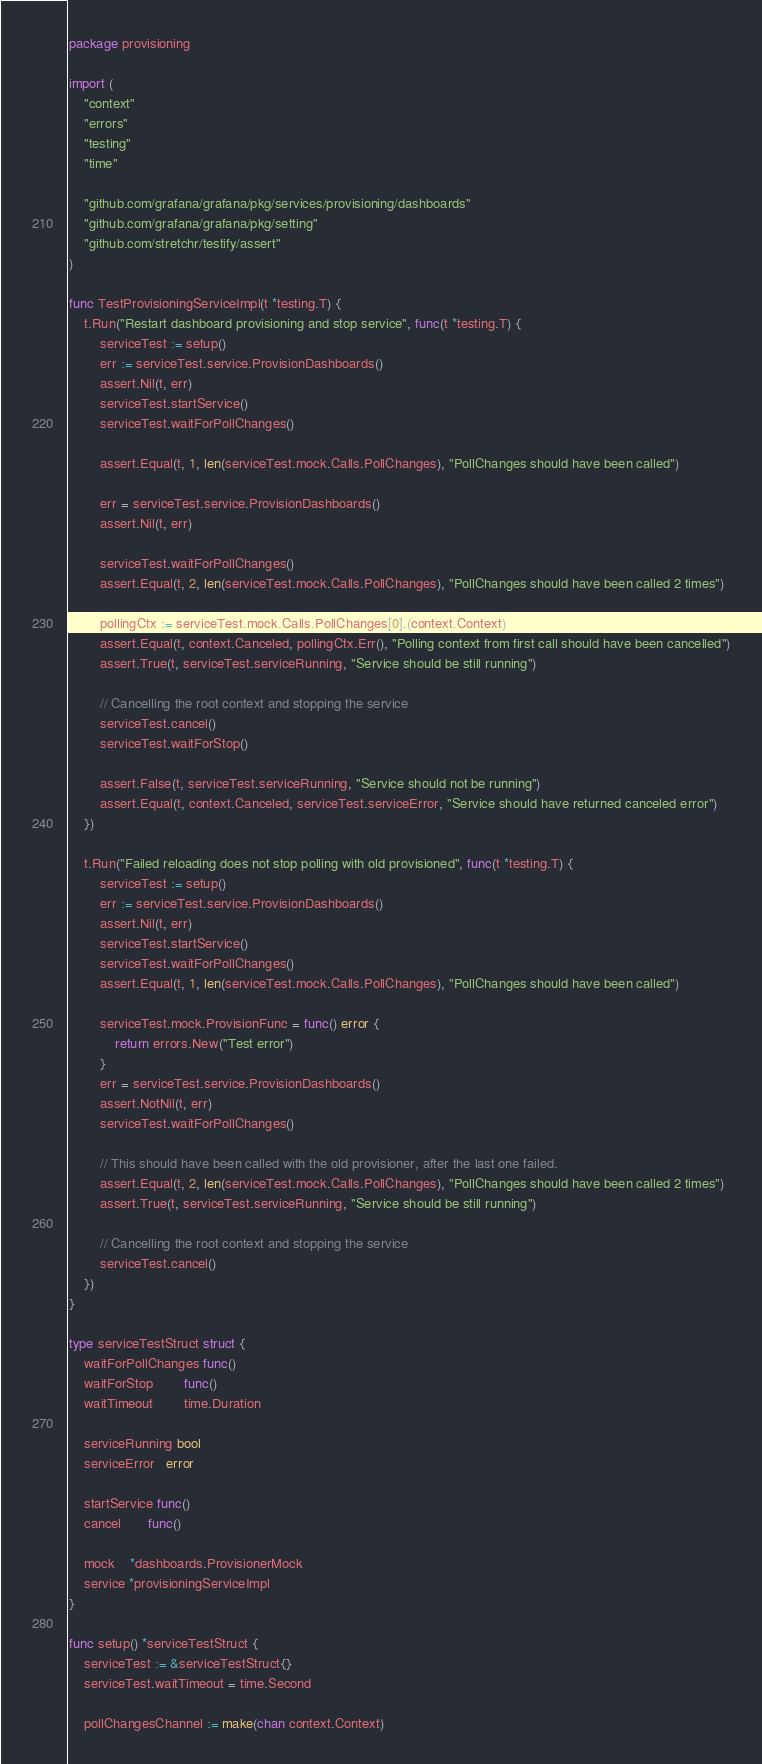Convert code to text. <code><loc_0><loc_0><loc_500><loc_500><_Go_>package provisioning

import (
	"context"
	"errors"
	"testing"
	"time"

	"github.com/grafana/grafana/pkg/services/provisioning/dashboards"
	"github.com/grafana/grafana/pkg/setting"
	"github.com/stretchr/testify/assert"
)

func TestProvisioningServiceImpl(t *testing.T) {
	t.Run("Restart dashboard provisioning and stop service", func(t *testing.T) {
		serviceTest := setup()
		err := serviceTest.service.ProvisionDashboards()
		assert.Nil(t, err)
		serviceTest.startService()
		serviceTest.waitForPollChanges()

		assert.Equal(t, 1, len(serviceTest.mock.Calls.PollChanges), "PollChanges should have been called")

		err = serviceTest.service.ProvisionDashboards()
		assert.Nil(t, err)

		serviceTest.waitForPollChanges()
		assert.Equal(t, 2, len(serviceTest.mock.Calls.PollChanges), "PollChanges should have been called 2 times")

		pollingCtx := serviceTest.mock.Calls.PollChanges[0].(context.Context)
		assert.Equal(t, context.Canceled, pollingCtx.Err(), "Polling context from first call should have been cancelled")
		assert.True(t, serviceTest.serviceRunning, "Service should be still running")

		// Cancelling the root context and stopping the service
		serviceTest.cancel()
		serviceTest.waitForStop()

		assert.False(t, serviceTest.serviceRunning, "Service should not be running")
		assert.Equal(t, context.Canceled, serviceTest.serviceError, "Service should have returned canceled error")
	})

	t.Run("Failed reloading does not stop polling with old provisioned", func(t *testing.T) {
		serviceTest := setup()
		err := serviceTest.service.ProvisionDashboards()
		assert.Nil(t, err)
		serviceTest.startService()
		serviceTest.waitForPollChanges()
		assert.Equal(t, 1, len(serviceTest.mock.Calls.PollChanges), "PollChanges should have been called")

		serviceTest.mock.ProvisionFunc = func() error {
			return errors.New("Test error")
		}
		err = serviceTest.service.ProvisionDashboards()
		assert.NotNil(t, err)
		serviceTest.waitForPollChanges()

		// This should have been called with the old provisioner, after the last one failed.
		assert.Equal(t, 2, len(serviceTest.mock.Calls.PollChanges), "PollChanges should have been called 2 times")
		assert.True(t, serviceTest.serviceRunning, "Service should be still running")

		// Cancelling the root context and stopping the service
		serviceTest.cancel()
	})
}

type serviceTestStruct struct {
	waitForPollChanges func()
	waitForStop        func()
	waitTimeout        time.Duration

	serviceRunning bool
	serviceError   error

	startService func()
	cancel       func()

	mock    *dashboards.ProvisionerMock
	service *provisioningServiceImpl
}

func setup() *serviceTestStruct {
	serviceTest := &serviceTestStruct{}
	serviceTest.waitTimeout = time.Second

	pollChangesChannel := make(chan context.Context)</code> 